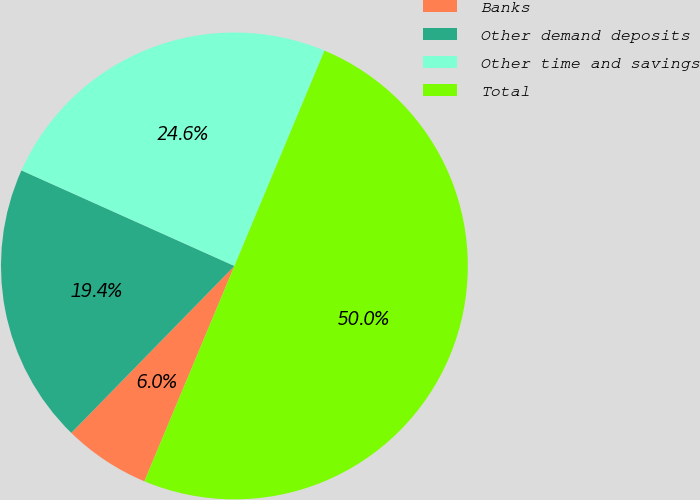<chart> <loc_0><loc_0><loc_500><loc_500><pie_chart><fcel>Banks<fcel>Other demand deposits<fcel>Other time and savings<fcel>Total<nl><fcel>6.01%<fcel>19.4%<fcel>24.59%<fcel>50.0%<nl></chart> 